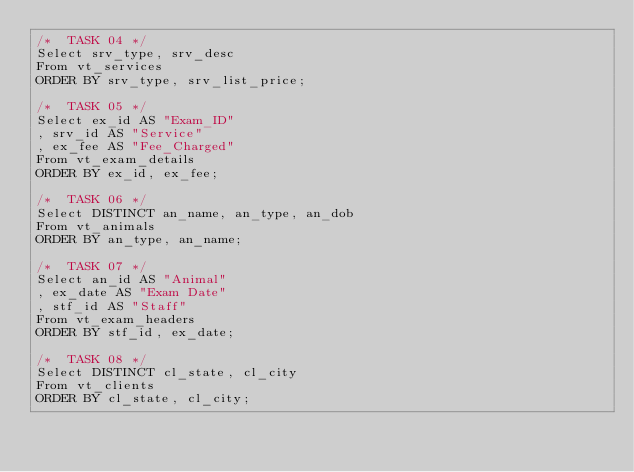Convert code to text. <code><loc_0><loc_0><loc_500><loc_500><_SQL_>/*  TASK 04 */
Select srv_type, srv_desc 
From vt_services 
ORDER BY srv_type, srv_list_price;

/*  TASK 05 */
Select ex_id AS "Exam_ID"
, srv_id AS "Service"
, ex_fee AS "Fee_Charged" 
From vt_exam_details 
ORDER BY ex_id, ex_fee;

/*  TASK 06 */
Select DISTINCT an_name, an_type, an_dob 
From vt_animals 
ORDER BY an_type, an_name;

/*  TASK 07 */
Select an_id AS "Animal"
, ex_date AS "Exam Date"
, stf_id AS "Staff" 
From vt_exam_headers 
ORDER BY stf_id, ex_date;

/*  TASK 08 */
Select DISTINCT cl_state, cl_city 
From vt_clients 
ORDER BY cl_state, cl_city;</code> 